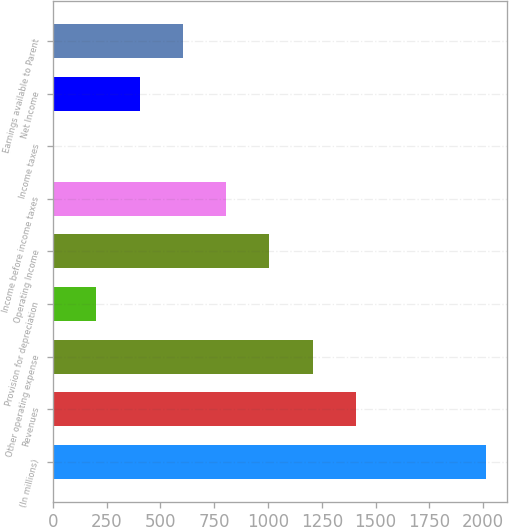<chart> <loc_0><loc_0><loc_500><loc_500><bar_chart><fcel>(In millions)<fcel>Revenues<fcel>Other operating expense<fcel>Provision for depreciation<fcel>Operating Income<fcel>Income before income taxes<fcel>Income taxes<fcel>Net Income<fcel>Earnings available to Parent<nl><fcel>2011<fcel>1408.12<fcel>1207.16<fcel>202.36<fcel>1006.2<fcel>805.24<fcel>1.4<fcel>403.32<fcel>604.28<nl></chart> 